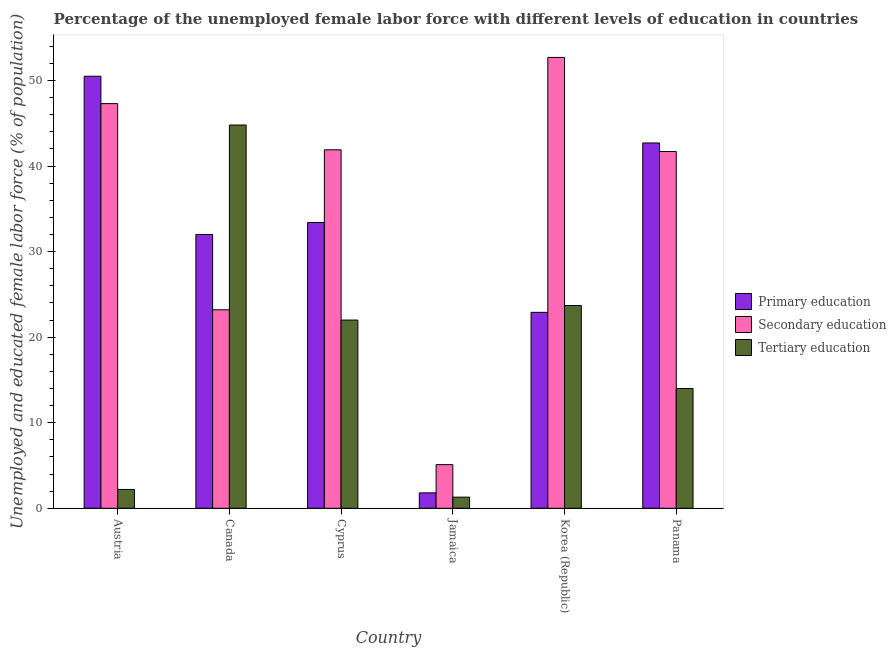Are the number of bars per tick equal to the number of legend labels?
Keep it short and to the point. Yes. Are the number of bars on each tick of the X-axis equal?
Your answer should be compact. Yes. What is the label of the 3rd group of bars from the left?
Your answer should be compact. Cyprus. What is the percentage of female labor force who received tertiary education in Jamaica?
Provide a succinct answer. 1.3. Across all countries, what is the maximum percentage of female labor force who received primary education?
Provide a succinct answer. 50.5. Across all countries, what is the minimum percentage of female labor force who received secondary education?
Ensure brevity in your answer.  5.1. In which country was the percentage of female labor force who received secondary education maximum?
Your answer should be compact. Korea (Republic). In which country was the percentage of female labor force who received primary education minimum?
Provide a short and direct response. Jamaica. What is the total percentage of female labor force who received tertiary education in the graph?
Your response must be concise. 108. What is the difference between the percentage of female labor force who received primary education in Austria and that in Canada?
Offer a terse response. 18.5. What is the difference between the percentage of female labor force who received primary education in Austria and the percentage of female labor force who received secondary education in Jamaica?
Provide a short and direct response. 45.4. What is the average percentage of female labor force who received secondary education per country?
Your response must be concise. 35.32. What is the difference between the percentage of female labor force who received primary education and percentage of female labor force who received secondary education in Jamaica?
Offer a very short reply. -3.3. What is the ratio of the percentage of female labor force who received secondary education in Austria to that in Canada?
Your answer should be very brief. 2.04. Is the difference between the percentage of female labor force who received secondary education in Canada and Jamaica greater than the difference between the percentage of female labor force who received primary education in Canada and Jamaica?
Provide a short and direct response. No. What is the difference between the highest and the second highest percentage of female labor force who received tertiary education?
Your response must be concise. 21.1. What is the difference between the highest and the lowest percentage of female labor force who received primary education?
Provide a short and direct response. 48.7. In how many countries, is the percentage of female labor force who received primary education greater than the average percentage of female labor force who received primary education taken over all countries?
Give a very brief answer. 4. Is the sum of the percentage of female labor force who received secondary education in Korea (Republic) and Panama greater than the maximum percentage of female labor force who received primary education across all countries?
Provide a succinct answer. Yes. What does the 3rd bar from the left in Canada represents?
Your response must be concise. Tertiary education. Is it the case that in every country, the sum of the percentage of female labor force who received primary education and percentage of female labor force who received secondary education is greater than the percentage of female labor force who received tertiary education?
Give a very brief answer. Yes. Are all the bars in the graph horizontal?
Your response must be concise. No. Does the graph contain any zero values?
Keep it short and to the point. No. Does the graph contain grids?
Make the answer very short. No. How are the legend labels stacked?
Your answer should be compact. Vertical. What is the title of the graph?
Your answer should be compact. Percentage of the unemployed female labor force with different levels of education in countries. What is the label or title of the X-axis?
Provide a short and direct response. Country. What is the label or title of the Y-axis?
Your response must be concise. Unemployed and educated female labor force (% of population). What is the Unemployed and educated female labor force (% of population) in Primary education in Austria?
Make the answer very short. 50.5. What is the Unemployed and educated female labor force (% of population) in Secondary education in Austria?
Your answer should be very brief. 47.3. What is the Unemployed and educated female labor force (% of population) of Tertiary education in Austria?
Your response must be concise. 2.2. What is the Unemployed and educated female labor force (% of population) of Primary education in Canada?
Ensure brevity in your answer.  32. What is the Unemployed and educated female labor force (% of population) of Secondary education in Canada?
Offer a very short reply. 23.2. What is the Unemployed and educated female labor force (% of population) of Tertiary education in Canada?
Your answer should be compact. 44.8. What is the Unemployed and educated female labor force (% of population) of Primary education in Cyprus?
Make the answer very short. 33.4. What is the Unemployed and educated female labor force (% of population) in Secondary education in Cyprus?
Provide a short and direct response. 41.9. What is the Unemployed and educated female labor force (% of population) in Tertiary education in Cyprus?
Keep it short and to the point. 22. What is the Unemployed and educated female labor force (% of population) of Primary education in Jamaica?
Give a very brief answer. 1.8. What is the Unemployed and educated female labor force (% of population) in Secondary education in Jamaica?
Provide a short and direct response. 5.1. What is the Unemployed and educated female labor force (% of population) in Tertiary education in Jamaica?
Give a very brief answer. 1.3. What is the Unemployed and educated female labor force (% of population) of Primary education in Korea (Republic)?
Your answer should be compact. 22.9. What is the Unemployed and educated female labor force (% of population) in Secondary education in Korea (Republic)?
Offer a very short reply. 52.7. What is the Unemployed and educated female labor force (% of population) in Tertiary education in Korea (Republic)?
Your answer should be very brief. 23.7. What is the Unemployed and educated female labor force (% of population) of Primary education in Panama?
Offer a terse response. 42.7. What is the Unemployed and educated female labor force (% of population) in Secondary education in Panama?
Your response must be concise. 41.7. Across all countries, what is the maximum Unemployed and educated female labor force (% of population) in Primary education?
Make the answer very short. 50.5. Across all countries, what is the maximum Unemployed and educated female labor force (% of population) of Secondary education?
Provide a succinct answer. 52.7. Across all countries, what is the maximum Unemployed and educated female labor force (% of population) of Tertiary education?
Your response must be concise. 44.8. Across all countries, what is the minimum Unemployed and educated female labor force (% of population) in Primary education?
Keep it short and to the point. 1.8. Across all countries, what is the minimum Unemployed and educated female labor force (% of population) of Secondary education?
Make the answer very short. 5.1. Across all countries, what is the minimum Unemployed and educated female labor force (% of population) in Tertiary education?
Your answer should be compact. 1.3. What is the total Unemployed and educated female labor force (% of population) in Primary education in the graph?
Give a very brief answer. 183.3. What is the total Unemployed and educated female labor force (% of population) in Secondary education in the graph?
Give a very brief answer. 211.9. What is the total Unemployed and educated female labor force (% of population) of Tertiary education in the graph?
Make the answer very short. 108. What is the difference between the Unemployed and educated female labor force (% of population) in Secondary education in Austria and that in Canada?
Your answer should be compact. 24.1. What is the difference between the Unemployed and educated female labor force (% of population) of Tertiary education in Austria and that in Canada?
Your response must be concise. -42.6. What is the difference between the Unemployed and educated female labor force (% of population) of Tertiary education in Austria and that in Cyprus?
Your response must be concise. -19.8. What is the difference between the Unemployed and educated female labor force (% of population) in Primary education in Austria and that in Jamaica?
Keep it short and to the point. 48.7. What is the difference between the Unemployed and educated female labor force (% of population) in Secondary education in Austria and that in Jamaica?
Your answer should be compact. 42.2. What is the difference between the Unemployed and educated female labor force (% of population) in Primary education in Austria and that in Korea (Republic)?
Your answer should be very brief. 27.6. What is the difference between the Unemployed and educated female labor force (% of population) in Secondary education in Austria and that in Korea (Republic)?
Provide a short and direct response. -5.4. What is the difference between the Unemployed and educated female labor force (% of population) in Tertiary education in Austria and that in Korea (Republic)?
Your answer should be compact. -21.5. What is the difference between the Unemployed and educated female labor force (% of population) in Primary education in Austria and that in Panama?
Ensure brevity in your answer.  7.8. What is the difference between the Unemployed and educated female labor force (% of population) of Secondary education in Austria and that in Panama?
Your answer should be very brief. 5.6. What is the difference between the Unemployed and educated female labor force (% of population) of Tertiary education in Austria and that in Panama?
Your answer should be compact. -11.8. What is the difference between the Unemployed and educated female labor force (% of population) in Primary education in Canada and that in Cyprus?
Give a very brief answer. -1.4. What is the difference between the Unemployed and educated female labor force (% of population) in Secondary education in Canada and that in Cyprus?
Provide a succinct answer. -18.7. What is the difference between the Unemployed and educated female labor force (% of population) of Tertiary education in Canada and that in Cyprus?
Offer a very short reply. 22.8. What is the difference between the Unemployed and educated female labor force (% of population) of Primary education in Canada and that in Jamaica?
Offer a terse response. 30.2. What is the difference between the Unemployed and educated female labor force (% of population) in Secondary education in Canada and that in Jamaica?
Keep it short and to the point. 18.1. What is the difference between the Unemployed and educated female labor force (% of population) in Tertiary education in Canada and that in Jamaica?
Ensure brevity in your answer.  43.5. What is the difference between the Unemployed and educated female labor force (% of population) in Secondary education in Canada and that in Korea (Republic)?
Make the answer very short. -29.5. What is the difference between the Unemployed and educated female labor force (% of population) in Tertiary education in Canada and that in Korea (Republic)?
Ensure brevity in your answer.  21.1. What is the difference between the Unemployed and educated female labor force (% of population) of Secondary education in Canada and that in Panama?
Provide a short and direct response. -18.5. What is the difference between the Unemployed and educated female labor force (% of population) in Tertiary education in Canada and that in Panama?
Provide a short and direct response. 30.8. What is the difference between the Unemployed and educated female labor force (% of population) of Primary education in Cyprus and that in Jamaica?
Your response must be concise. 31.6. What is the difference between the Unemployed and educated female labor force (% of population) of Secondary education in Cyprus and that in Jamaica?
Ensure brevity in your answer.  36.8. What is the difference between the Unemployed and educated female labor force (% of population) in Tertiary education in Cyprus and that in Jamaica?
Provide a short and direct response. 20.7. What is the difference between the Unemployed and educated female labor force (% of population) in Tertiary education in Cyprus and that in Korea (Republic)?
Provide a short and direct response. -1.7. What is the difference between the Unemployed and educated female labor force (% of population) in Secondary education in Cyprus and that in Panama?
Give a very brief answer. 0.2. What is the difference between the Unemployed and educated female labor force (% of population) in Primary education in Jamaica and that in Korea (Republic)?
Provide a succinct answer. -21.1. What is the difference between the Unemployed and educated female labor force (% of population) in Secondary education in Jamaica and that in Korea (Republic)?
Your answer should be compact. -47.6. What is the difference between the Unemployed and educated female labor force (% of population) in Tertiary education in Jamaica and that in Korea (Republic)?
Your answer should be compact. -22.4. What is the difference between the Unemployed and educated female labor force (% of population) in Primary education in Jamaica and that in Panama?
Give a very brief answer. -40.9. What is the difference between the Unemployed and educated female labor force (% of population) of Secondary education in Jamaica and that in Panama?
Your answer should be very brief. -36.6. What is the difference between the Unemployed and educated female labor force (% of population) of Primary education in Korea (Republic) and that in Panama?
Keep it short and to the point. -19.8. What is the difference between the Unemployed and educated female labor force (% of population) in Primary education in Austria and the Unemployed and educated female labor force (% of population) in Secondary education in Canada?
Provide a short and direct response. 27.3. What is the difference between the Unemployed and educated female labor force (% of population) in Primary education in Austria and the Unemployed and educated female labor force (% of population) in Tertiary education in Canada?
Offer a very short reply. 5.7. What is the difference between the Unemployed and educated female labor force (% of population) in Secondary education in Austria and the Unemployed and educated female labor force (% of population) in Tertiary education in Cyprus?
Make the answer very short. 25.3. What is the difference between the Unemployed and educated female labor force (% of population) of Primary education in Austria and the Unemployed and educated female labor force (% of population) of Secondary education in Jamaica?
Your response must be concise. 45.4. What is the difference between the Unemployed and educated female labor force (% of population) in Primary education in Austria and the Unemployed and educated female labor force (% of population) in Tertiary education in Jamaica?
Make the answer very short. 49.2. What is the difference between the Unemployed and educated female labor force (% of population) of Secondary education in Austria and the Unemployed and educated female labor force (% of population) of Tertiary education in Jamaica?
Make the answer very short. 46. What is the difference between the Unemployed and educated female labor force (% of population) of Primary education in Austria and the Unemployed and educated female labor force (% of population) of Tertiary education in Korea (Republic)?
Give a very brief answer. 26.8. What is the difference between the Unemployed and educated female labor force (% of population) in Secondary education in Austria and the Unemployed and educated female labor force (% of population) in Tertiary education in Korea (Republic)?
Make the answer very short. 23.6. What is the difference between the Unemployed and educated female labor force (% of population) in Primary education in Austria and the Unemployed and educated female labor force (% of population) in Tertiary education in Panama?
Provide a short and direct response. 36.5. What is the difference between the Unemployed and educated female labor force (% of population) of Secondary education in Austria and the Unemployed and educated female labor force (% of population) of Tertiary education in Panama?
Offer a terse response. 33.3. What is the difference between the Unemployed and educated female labor force (% of population) in Primary education in Canada and the Unemployed and educated female labor force (% of population) in Tertiary education in Cyprus?
Offer a terse response. 10. What is the difference between the Unemployed and educated female labor force (% of population) of Secondary education in Canada and the Unemployed and educated female labor force (% of population) of Tertiary education in Cyprus?
Your response must be concise. 1.2. What is the difference between the Unemployed and educated female labor force (% of population) in Primary education in Canada and the Unemployed and educated female labor force (% of population) in Secondary education in Jamaica?
Keep it short and to the point. 26.9. What is the difference between the Unemployed and educated female labor force (% of population) of Primary education in Canada and the Unemployed and educated female labor force (% of population) of Tertiary education in Jamaica?
Offer a very short reply. 30.7. What is the difference between the Unemployed and educated female labor force (% of population) of Secondary education in Canada and the Unemployed and educated female labor force (% of population) of Tertiary education in Jamaica?
Provide a succinct answer. 21.9. What is the difference between the Unemployed and educated female labor force (% of population) in Primary education in Canada and the Unemployed and educated female labor force (% of population) in Secondary education in Korea (Republic)?
Keep it short and to the point. -20.7. What is the difference between the Unemployed and educated female labor force (% of population) of Primary education in Canada and the Unemployed and educated female labor force (% of population) of Tertiary education in Korea (Republic)?
Your answer should be compact. 8.3. What is the difference between the Unemployed and educated female labor force (% of population) in Secondary education in Canada and the Unemployed and educated female labor force (% of population) in Tertiary education in Korea (Republic)?
Ensure brevity in your answer.  -0.5. What is the difference between the Unemployed and educated female labor force (% of population) in Primary education in Canada and the Unemployed and educated female labor force (% of population) in Tertiary education in Panama?
Give a very brief answer. 18. What is the difference between the Unemployed and educated female labor force (% of population) of Primary education in Cyprus and the Unemployed and educated female labor force (% of population) of Secondary education in Jamaica?
Your answer should be very brief. 28.3. What is the difference between the Unemployed and educated female labor force (% of population) of Primary education in Cyprus and the Unemployed and educated female labor force (% of population) of Tertiary education in Jamaica?
Provide a succinct answer. 32.1. What is the difference between the Unemployed and educated female labor force (% of population) of Secondary education in Cyprus and the Unemployed and educated female labor force (% of population) of Tertiary education in Jamaica?
Provide a short and direct response. 40.6. What is the difference between the Unemployed and educated female labor force (% of population) in Primary education in Cyprus and the Unemployed and educated female labor force (% of population) in Secondary education in Korea (Republic)?
Your answer should be compact. -19.3. What is the difference between the Unemployed and educated female labor force (% of population) in Primary education in Cyprus and the Unemployed and educated female labor force (% of population) in Secondary education in Panama?
Give a very brief answer. -8.3. What is the difference between the Unemployed and educated female labor force (% of population) in Secondary education in Cyprus and the Unemployed and educated female labor force (% of population) in Tertiary education in Panama?
Make the answer very short. 27.9. What is the difference between the Unemployed and educated female labor force (% of population) in Primary education in Jamaica and the Unemployed and educated female labor force (% of population) in Secondary education in Korea (Republic)?
Offer a terse response. -50.9. What is the difference between the Unemployed and educated female labor force (% of population) in Primary education in Jamaica and the Unemployed and educated female labor force (% of population) in Tertiary education in Korea (Republic)?
Provide a short and direct response. -21.9. What is the difference between the Unemployed and educated female labor force (% of population) of Secondary education in Jamaica and the Unemployed and educated female labor force (% of population) of Tertiary education in Korea (Republic)?
Your response must be concise. -18.6. What is the difference between the Unemployed and educated female labor force (% of population) in Primary education in Jamaica and the Unemployed and educated female labor force (% of population) in Secondary education in Panama?
Your response must be concise. -39.9. What is the difference between the Unemployed and educated female labor force (% of population) in Primary education in Jamaica and the Unemployed and educated female labor force (% of population) in Tertiary education in Panama?
Make the answer very short. -12.2. What is the difference between the Unemployed and educated female labor force (% of population) of Primary education in Korea (Republic) and the Unemployed and educated female labor force (% of population) of Secondary education in Panama?
Your answer should be compact. -18.8. What is the difference between the Unemployed and educated female labor force (% of population) of Primary education in Korea (Republic) and the Unemployed and educated female labor force (% of population) of Tertiary education in Panama?
Offer a very short reply. 8.9. What is the difference between the Unemployed and educated female labor force (% of population) of Secondary education in Korea (Republic) and the Unemployed and educated female labor force (% of population) of Tertiary education in Panama?
Your response must be concise. 38.7. What is the average Unemployed and educated female labor force (% of population) of Primary education per country?
Keep it short and to the point. 30.55. What is the average Unemployed and educated female labor force (% of population) in Secondary education per country?
Your answer should be very brief. 35.32. What is the average Unemployed and educated female labor force (% of population) in Tertiary education per country?
Provide a short and direct response. 18. What is the difference between the Unemployed and educated female labor force (% of population) in Primary education and Unemployed and educated female labor force (% of population) in Secondary education in Austria?
Your answer should be very brief. 3.2. What is the difference between the Unemployed and educated female labor force (% of population) in Primary education and Unemployed and educated female labor force (% of population) in Tertiary education in Austria?
Ensure brevity in your answer.  48.3. What is the difference between the Unemployed and educated female labor force (% of population) of Secondary education and Unemployed and educated female labor force (% of population) of Tertiary education in Austria?
Your answer should be very brief. 45.1. What is the difference between the Unemployed and educated female labor force (% of population) in Secondary education and Unemployed and educated female labor force (% of population) in Tertiary education in Canada?
Your answer should be compact. -21.6. What is the difference between the Unemployed and educated female labor force (% of population) of Primary education and Unemployed and educated female labor force (% of population) of Tertiary education in Cyprus?
Your response must be concise. 11.4. What is the difference between the Unemployed and educated female labor force (% of population) in Primary education and Unemployed and educated female labor force (% of population) in Tertiary education in Jamaica?
Keep it short and to the point. 0.5. What is the difference between the Unemployed and educated female labor force (% of population) in Primary education and Unemployed and educated female labor force (% of population) in Secondary education in Korea (Republic)?
Your response must be concise. -29.8. What is the difference between the Unemployed and educated female labor force (% of population) in Primary education and Unemployed and educated female labor force (% of population) in Tertiary education in Korea (Republic)?
Keep it short and to the point. -0.8. What is the difference between the Unemployed and educated female labor force (% of population) in Primary education and Unemployed and educated female labor force (% of population) in Tertiary education in Panama?
Offer a terse response. 28.7. What is the difference between the Unemployed and educated female labor force (% of population) of Secondary education and Unemployed and educated female labor force (% of population) of Tertiary education in Panama?
Make the answer very short. 27.7. What is the ratio of the Unemployed and educated female labor force (% of population) of Primary education in Austria to that in Canada?
Your answer should be very brief. 1.58. What is the ratio of the Unemployed and educated female labor force (% of population) in Secondary education in Austria to that in Canada?
Offer a very short reply. 2.04. What is the ratio of the Unemployed and educated female labor force (% of population) in Tertiary education in Austria to that in Canada?
Provide a short and direct response. 0.05. What is the ratio of the Unemployed and educated female labor force (% of population) in Primary education in Austria to that in Cyprus?
Offer a terse response. 1.51. What is the ratio of the Unemployed and educated female labor force (% of population) of Secondary education in Austria to that in Cyprus?
Your answer should be very brief. 1.13. What is the ratio of the Unemployed and educated female labor force (% of population) in Primary education in Austria to that in Jamaica?
Your response must be concise. 28.06. What is the ratio of the Unemployed and educated female labor force (% of population) in Secondary education in Austria to that in Jamaica?
Your response must be concise. 9.27. What is the ratio of the Unemployed and educated female labor force (% of population) of Tertiary education in Austria to that in Jamaica?
Provide a short and direct response. 1.69. What is the ratio of the Unemployed and educated female labor force (% of population) in Primary education in Austria to that in Korea (Republic)?
Make the answer very short. 2.21. What is the ratio of the Unemployed and educated female labor force (% of population) of Secondary education in Austria to that in Korea (Republic)?
Keep it short and to the point. 0.9. What is the ratio of the Unemployed and educated female labor force (% of population) in Tertiary education in Austria to that in Korea (Republic)?
Provide a short and direct response. 0.09. What is the ratio of the Unemployed and educated female labor force (% of population) in Primary education in Austria to that in Panama?
Your answer should be very brief. 1.18. What is the ratio of the Unemployed and educated female labor force (% of population) in Secondary education in Austria to that in Panama?
Your response must be concise. 1.13. What is the ratio of the Unemployed and educated female labor force (% of population) in Tertiary education in Austria to that in Panama?
Make the answer very short. 0.16. What is the ratio of the Unemployed and educated female labor force (% of population) in Primary education in Canada to that in Cyprus?
Your answer should be compact. 0.96. What is the ratio of the Unemployed and educated female labor force (% of population) in Secondary education in Canada to that in Cyprus?
Ensure brevity in your answer.  0.55. What is the ratio of the Unemployed and educated female labor force (% of population) in Tertiary education in Canada to that in Cyprus?
Provide a succinct answer. 2.04. What is the ratio of the Unemployed and educated female labor force (% of population) of Primary education in Canada to that in Jamaica?
Offer a terse response. 17.78. What is the ratio of the Unemployed and educated female labor force (% of population) of Secondary education in Canada to that in Jamaica?
Keep it short and to the point. 4.55. What is the ratio of the Unemployed and educated female labor force (% of population) of Tertiary education in Canada to that in Jamaica?
Provide a short and direct response. 34.46. What is the ratio of the Unemployed and educated female labor force (% of population) in Primary education in Canada to that in Korea (Republic)?
Keep it short and to the point. 1.4. What is the ratio of the Unemployed and educated female labor force (% of population) in Secondary education in Canada to that in Korea (Republic)?
Offer a very short reply. 0.44. What is the ratio of the Unemployed and educated female labor force (% of population) of Tertiary education in Canada to that in Korea (Republic)?
Offer a very short reply. 1.89. What is the ratio of the Unemployed and educated female labor force (% of population) of Primary education in Canada to that in Panama?
Offer a terse response. 0.75. What is the ratio of the Unemployed and educated female labor force (% of population) in Secondary education in Canada to that in Panama?
Your answer should be very brief. 0.56. What is the ratio of the Unemployed and educated female labor force (% of population) in Primary education in Cyprus to that in Jamaica?
Keep it short and to the point. 18.56. What is the ratio of the Unemployed and educated female labor force (% of population) of Secondary education in Cyprus to that in Jamaica?
Ensure brevity in your answer.  8.22. What is the ratio of the Unemployed and educated female labor force (% of population) of Tertiary education in Cyprus to that in Jamaica?
Your answer should be compact. 16.92. What is the ratio of the Unemployed and educated female labor force (% of population) of Primary education in Cyprus to that in Korea (Republic)?
Offer a very short reply. 1.46. What is the ratio of the Unemployed and educated female labor force (% of population) in Secondary education in Cyprus to that in Korea (Republic)?
Offer a very short reply. 0.8. What is the ratio of the Unemployed and educated female labor force (% of population) of Tertiary education in Cyprus to that in Korea (Republic)?
Provide a short and direct response. 0.93. What is the ratio of the Unemployed and educated female labor force (% of population) of Primary education in Cyprus to that in Panama?
Ensure brevity in your answer.  0.78. What is the ratio of the Unemployed and educated female labor force (% of population) of Tertiary education in Cyprus to that in Panama?
Provide a short and direct response. 1.57. What is the ratio of the Unemployed and educated female labor force (% of population) of Primary education in Jamaica to that in Korea (Republic)?
Your answer should be very brief. 0.08. What is the ratio of the Unemployed and educated female labor force (% of population) of Secondary education in Jamaica to that in Korea (Republic)?
Your answer should be very brief. 0.1. What is the ratio of the Unemployed and educated female labor force (% of population) in Tertiary education in Jamaica to that in Korea (Republic)?
Provide a short and direct response. 0.05. What is the ratio of the Unemployed and educated female labor force (% of population) in Primary education in Jamaica to that in Panama?
Keep it short and to the point. 0.04. What is the ratio of the Unemployed and educated female labor force (% of population) of Secondary education in Jamaica to that in Panama?
Your response must be concise. 0.12. What is the ratio of the Unemployed and educated female labor force (% of population) of Tertiary education in Jamaica to that in Panama?
Ensure brevity in your answer.  0.09. What is the ratio of the Unemployed and educated female labor force (% of population) in Primary education in Korea (Republic) to that in Panama?
Offer a terse response. 0.54. What is the ratio of the Unemployed and educated female labor force (% of population) of Secondary education in Korea (Republic) to that in Panama?
Your response must be concise. 1.26. What is the ratio of the Unemployed and educated female labor force (% of population) of Tertiary education in Korea (Republic) to that in Panama?
Keep it short and to the point. 1.69. What is the difference between the highest and the second highest Unemployed and educated female labor force (% of population) of Secondary education?
Offer a terse response. 5.4. What is the difference between the highest and the second highest Unemployed and educated female labor force (% of population) of Tertiary education?
Provide a succinct answer. 21.1. What is the difference between the highest and the lowest Unemployed and educated female labor force (% of population) in Primary education?
Give a very brief answer. 48.7. What is the difference between the highest and the lowest Unemployed and educated female labor force (% of population) of Secondary education?
Offer a very short reply. 47.6. What is the difference between the highest and the lowest Unemployed and educated female labor force (% of population) of Tertiary education?
Your answer should be compact. 43.5. 